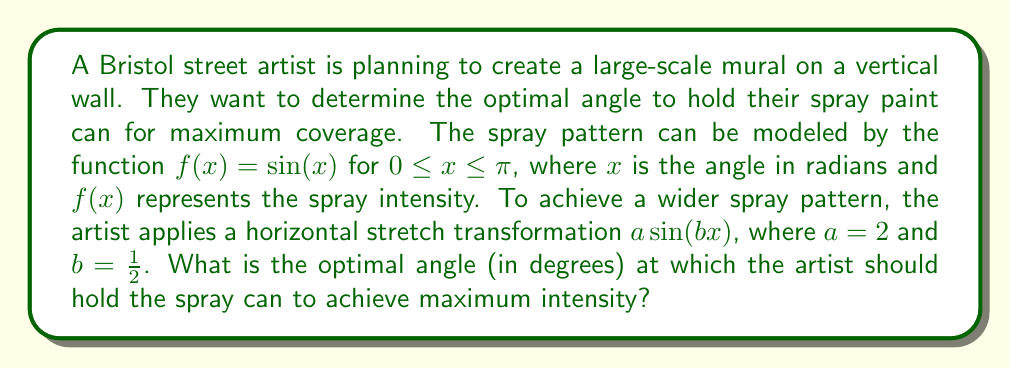Provide a solution to this math problem. Let's approach this step-by-step:

1) The original function is $f(x) = \sin(x)$. After the transformation, we have:

   $g(x) = 2\sin(\frac{1}{2}x)$

2) To find the maximum value of this function, we need to find where its derivative equals zero:

   $g'(x) = 2 \cdot \frac{1}{2} \cos(\frac{1}{2}x) = \cos(\frac{1}{2}x)$

3) Set this equal to zero:

   $\cos(\frac{1}{2}x) = 0$

4) We know that cosine equals zero when its argument is $\frac{\pi}{2}$ (or odd multiples of it). So:

   $\frac{1}{2}x = \frac{\pi}{2}$

5) Solve for x:

   $x = \pi$

6) This is the solution in radians. To convert to degrees, we multiply by $\frac{180}{\pi}$:

   $x = \pi \cdot \frac{180}{\pi} = 180°$

Therefore, the optimal angle is 180°.

[asy]
import graph;
size(200,150);
real f(real x) {return 2*sin(x/2);}
draw(graph(f,0,2*pi));
draw((0,0)--(2*pi,0),arrow=Arrow(TeXHead));
draw((0,-2)--(0,2),arrow=Arrow(TeXHead));
label("$x$",(2*pi,0),SE);
label("$y$",(0,2),NW);
dot((pi,2));
label("(180°, 2)",(pi,2),NE);
[/asy]
Answer: The optimal angle at which the artist should hold the spray can is 180°. 